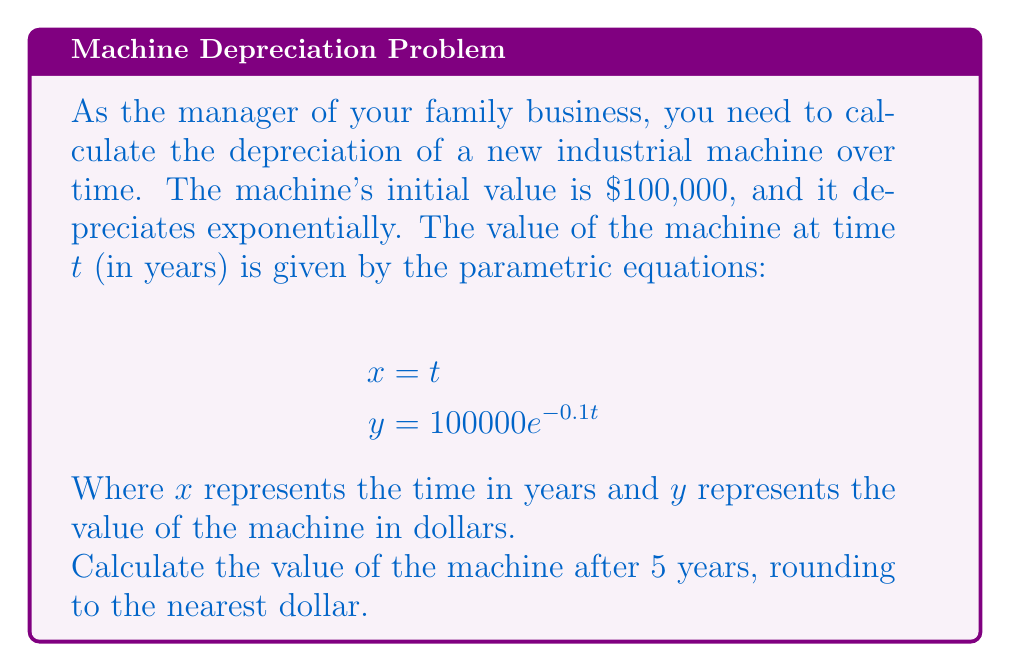Help me with this question. To solve this problem, we'll follow these steps:

1) We're given the parametric equations:
   $$x = t$$
   $$y = 100000e^{-0.1t}$$

2) We need to find the value of y when x (or t) is 5 years.

3) Substitute t = 5 into the equation for y:
   $$y = 100000e^{-0.1(5)}$$

4) Simplify the exponent:
   $$y = 100000e^{-0.5}$$

5) Calculate this value:
   $$y = 100000 * (e^{-0.5})$$
   $$y = 100000 * 0.6065306597$$
   $$y = 60653.06597$$

6) Rounding to the nearest dollar:
   $$y ≈ 60653$$

Therefore, after 5 years, the machine will be worth approximately $60,653.
Answer: $60,653 